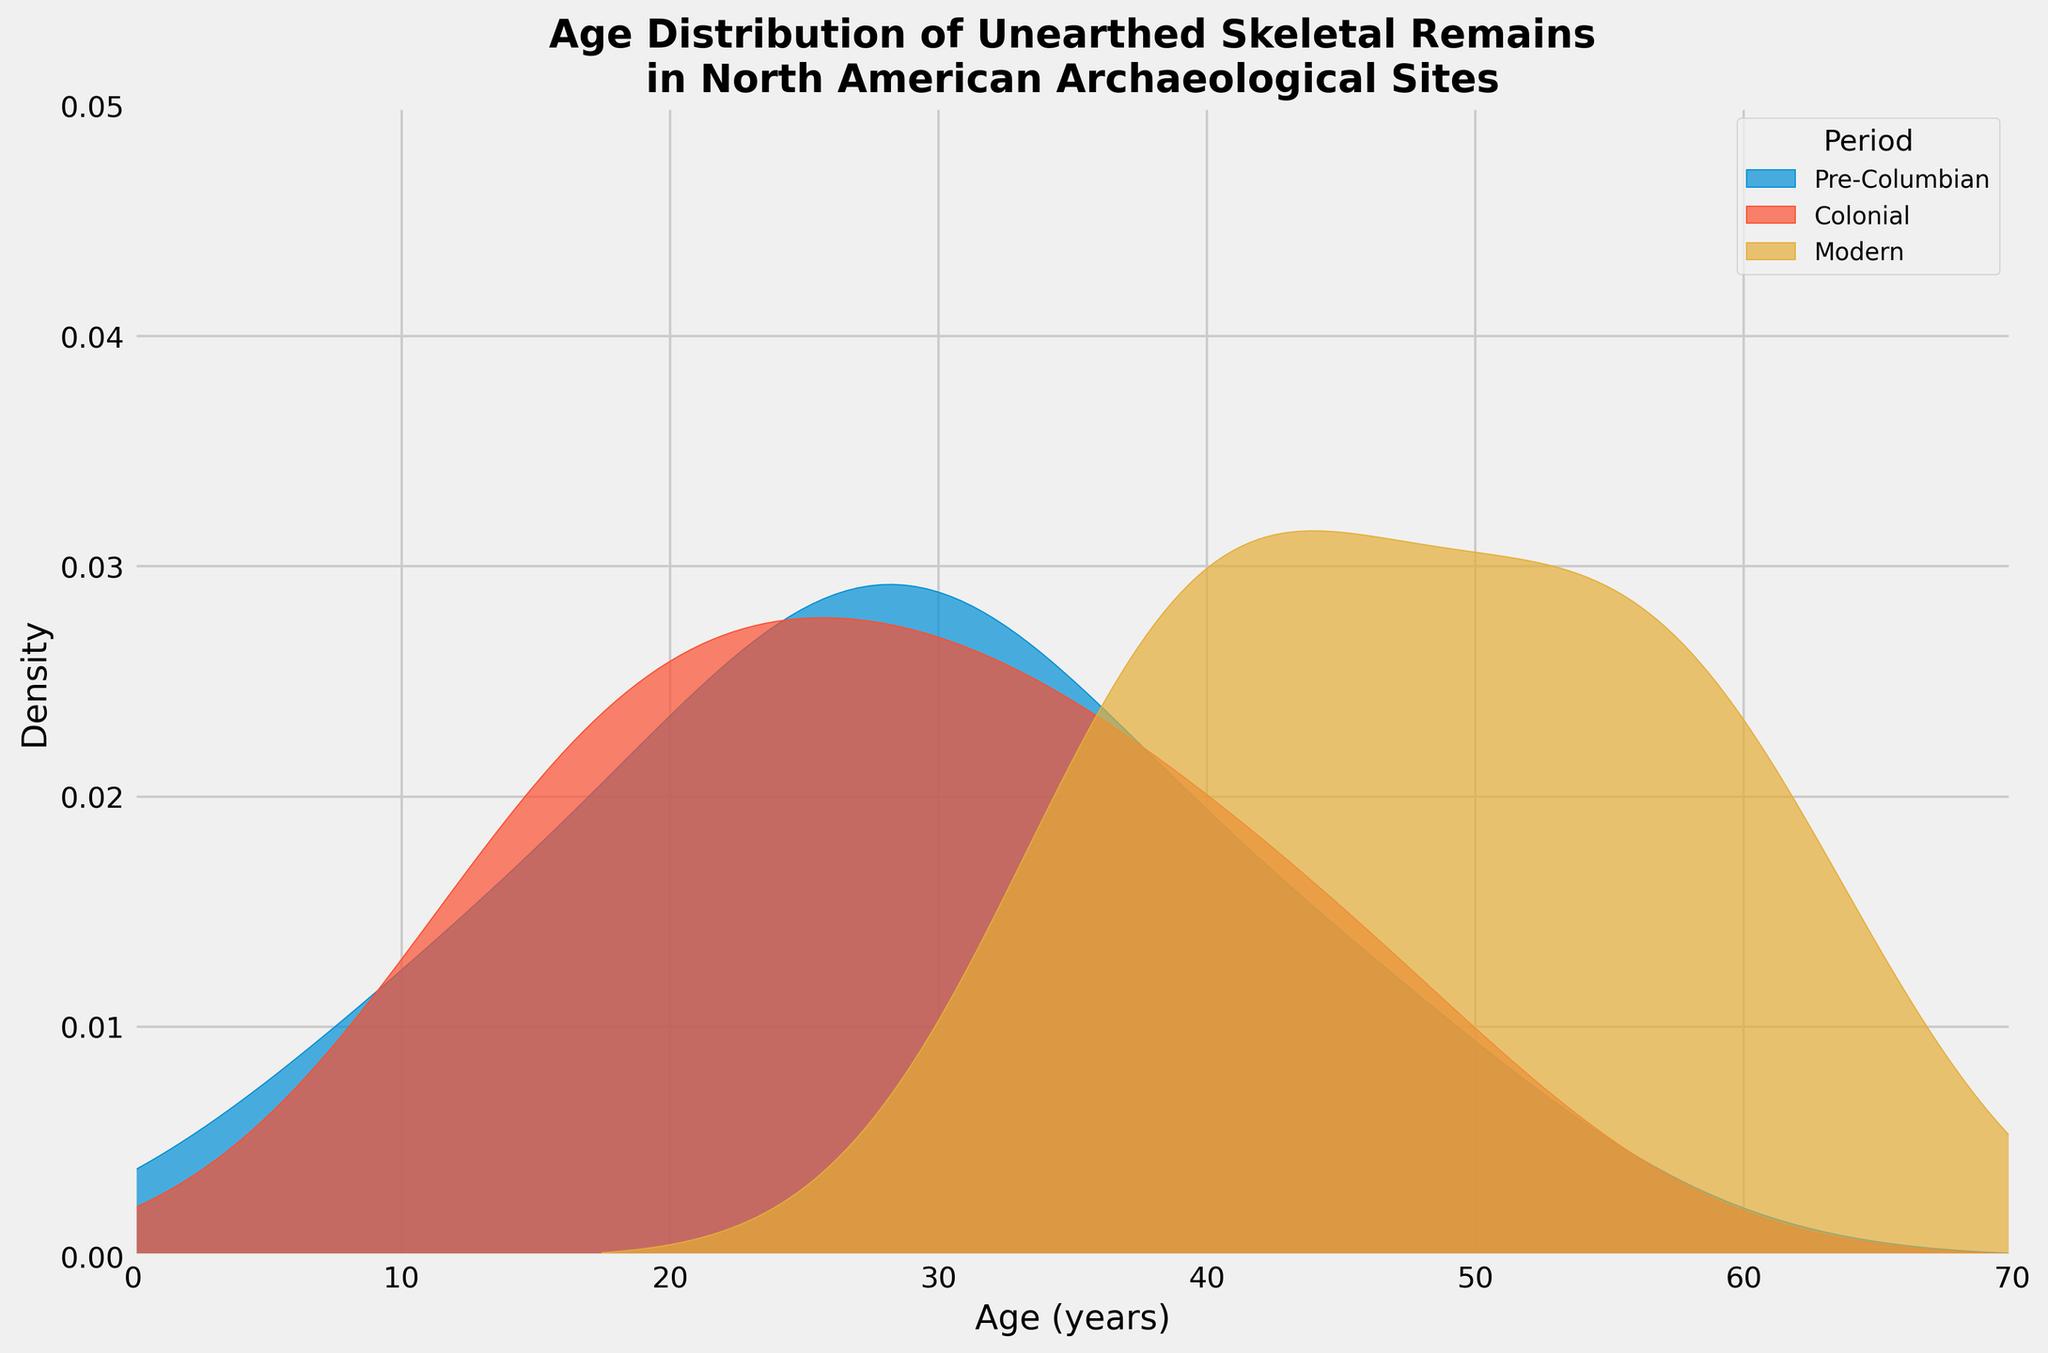What are the three periods shown in the figure? The title of the figure refers to periods in the data, and the legend includes the periods.
Answer: Pre-Columbian, Colonial, Modern What is the approximate age range covered by the Modern period? Look at the x-axis under the density curve for the Modern period’s color in the legend.
Answer: 30 to 70 years Which period has the highest density peak? Observe the peak density heights of the curves in the figure.
Answer: Pre-Columbian What is the approximate age of the highest density peak for the Colonial period? Identify the peak of the Colonial period curve and read the age on the x-axis.
Answer: Around 20 years Is the age distribution of remains in the Pre-Columbian period more spread out compared to the Colonial period? Look at the width and spread of the density curves for Pre-Columbian and Colonial periods.
Answer: Yes Which period has the remains with the highest maximum age? Check which period's curve extends furthest to the right on the x-axis.
Answer: Modern Do all periods show some skeletal remains in the age range of 40s? Check if the density curves for all periods overlap the age of 40 on the x-axis.
Answer: Yes Which period has the least pronounced peak? Compare the peak heights of the density curves and find the one that’s least sharp.
Answer: Modern What is the approximate age range with significant density overlap among all three periods? Look at the overlapping parts of the density curves and estimate the common age range.
Answer: 25 to 45 years 